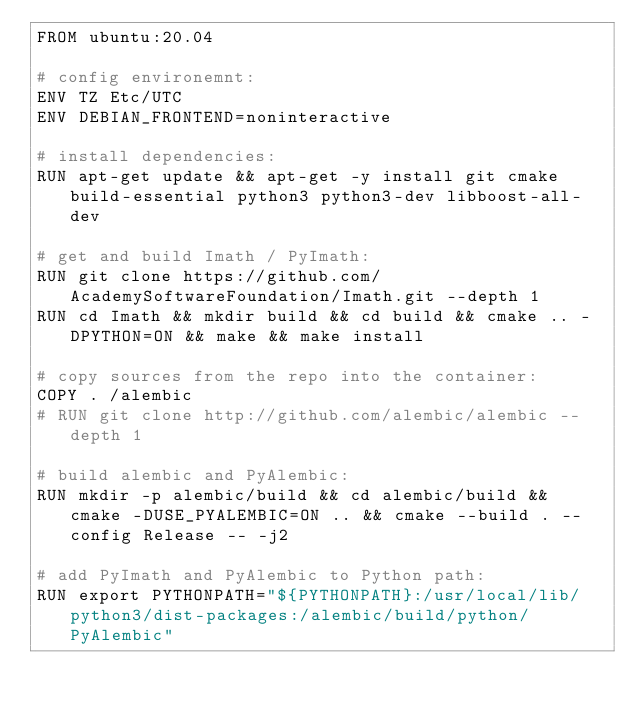Convert code to text. <code><loc_0><loc_0><loc_500><loc_500><_Dockerfile_>FROM ubuntu:20.04

# config environemnt:
ENV TZ Etc/UTC
ENV DEBIAN_FRONTEND=noninteractive

# install dependencies:
RUN apt-get update && apt-get -y install git cmake build-essential python3 python3-dev libboost-all-dev

# get and build Imath / PyImath:
RUN git clone https://github.com/AcademySoftwareFoundation/Imath.git --depth 1
RUN cd Imath && mkdir build && cd build && cmake .. -DPYTHON=ON && make && make install

# copy sources from the repo into the container:
COPY . /alembic
# RUN git clone http://github.com/alembic/alembic --depth 1

# build alembic and PyAlembic:
RUN mkdir -p alembic/build && cd alembic/build && cmake -DUSE_PYALEMBIC=ON .. && cmake --build . --config Release -- -j2

# add PyImath and PyAlembic to Python path:
RUN export PYTHONPATH="${PYTHONPATH}:/usr/local/lib/python3/dist-packages:/alembic/build/python/PyAlembic"
</code> 